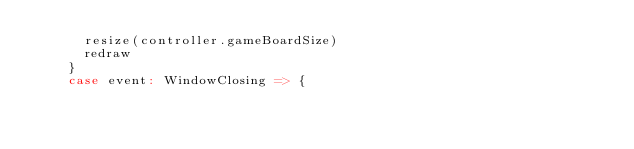Convert code to text. <code><loc_0><loc_0><loc_500><loc_500><_Scala_>      resize(controller.gameBoardSize)
      redraw
    }
    case event: WindowClosing => {</code> 